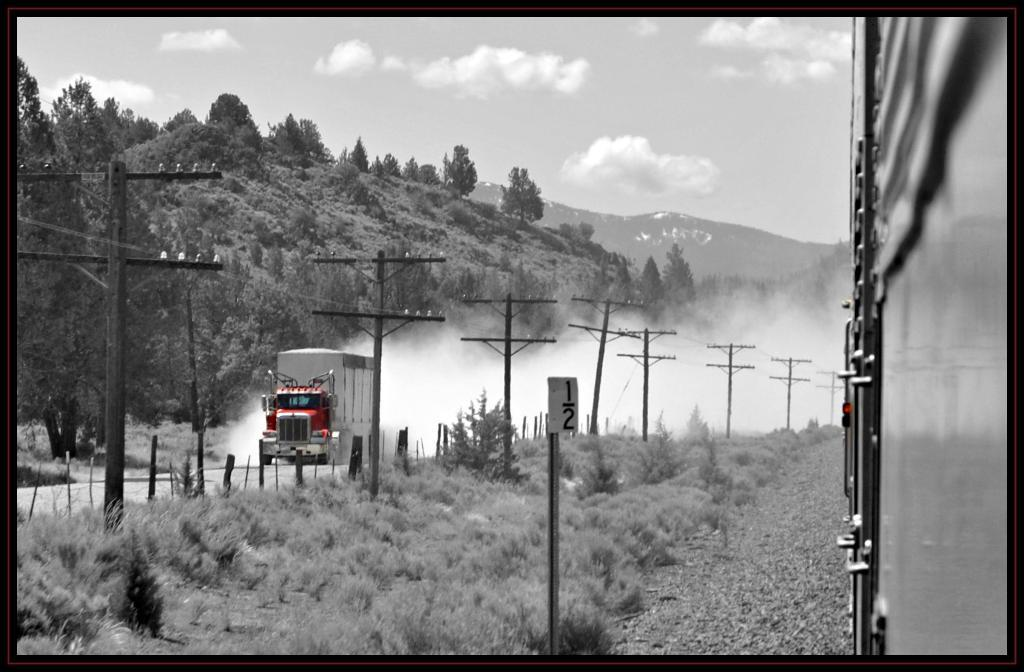What can be seen in the foreground of the image? In the foreground of the image, there are trees, a fence, electric poles, a train, and a truck on the road. What is the setting of the image? The image is taken on the road. What can be seen in the background of the image? In the background of the image, there are mountains and the sky. What type of lawyer is sitting by the window in the image? There is no lawyer or window present in the image. How does the truck rest on the road in the image? The truck is not resting in the image; it is moving on the road. 